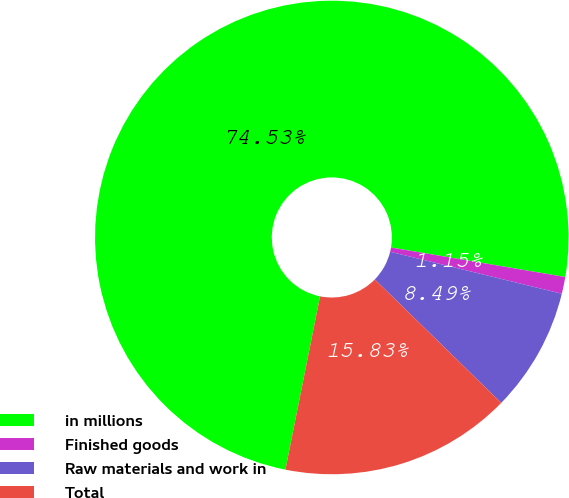<chart> <loc_0><loc_0><loc_500><loc_500><pie_chart><fcel>in millions<fcel>Finished goods<fcel>Raw materials and work in<fcel>Total<nl><fcel>74.53%<fcel>1.15%<fcel>8.49%<fcel>15.83%<nl></chart> 